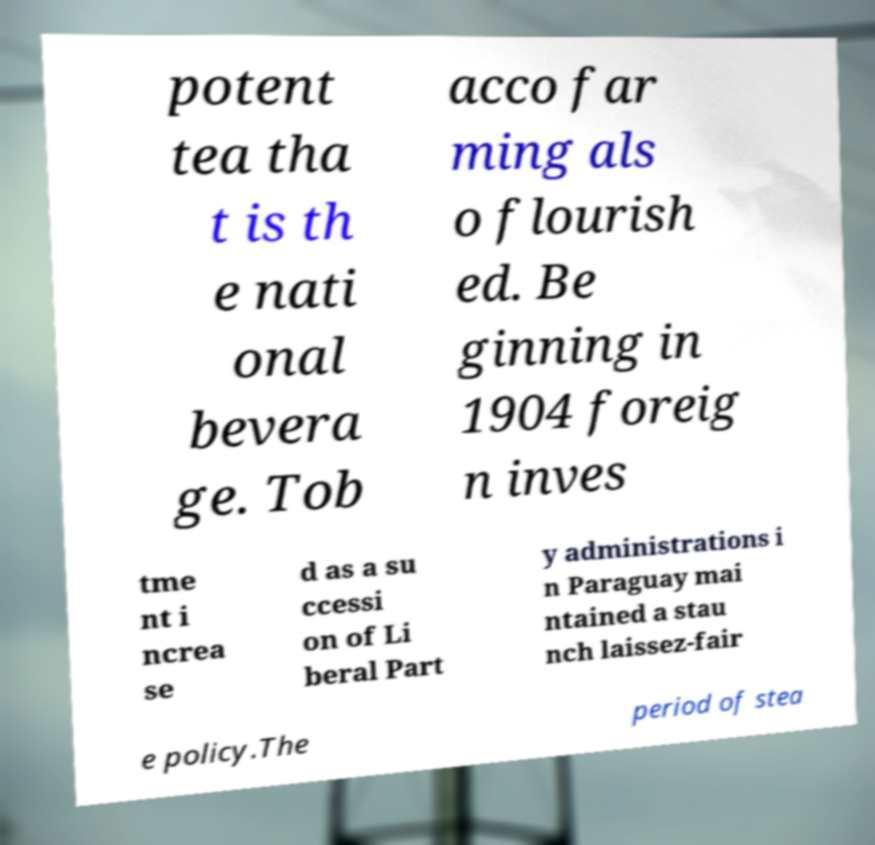I need the written content from this picture converted into text. Can you do that? potent tea tha t is th e nati onal bevera ge. Tob acco far ming als o flourish ed. Be ginning in 1904 foreig n inves tme nt i ncrea se d as a su ccessi on of Li beral Part y administrations i n Paraguay mai ntained a stau nch laissez-fair e policy.The period of stea 